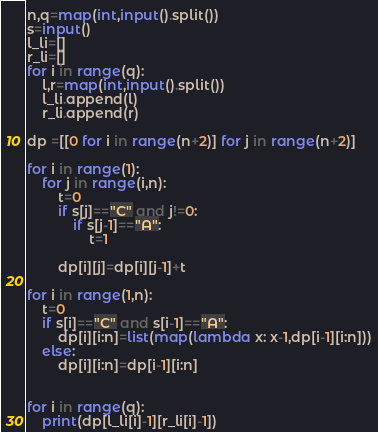<code> <loc_0><loc_0><loc_500><loc_500><_Python_>n,q=map(int,input().split())
s=input()
l_li=[]
r_li=[]
for i in range(q):
    l,r=map(int,input().split())
    l_li.append(l)
    r_li.append(r)
    
dp =[[0 for i in range(n+2)] for j in range(n+2)]

for i in range(1):
    for j in range(i,n):
        t=0
        if s[j]=="C" and j!=0:
            if s[j-1]=="A":
                t=1
        
        dp[i][j]=dp[i][j-1]+t
        
for i in range(1,n):
    t=0
    if s[i]=="C" and s[i-1]=="A":   
        dp[i][i:n]=list(map(lambda x: x-1,dp[i-1][i:n]))
    else:
        dp[i][i:n]=dp[i-1][i:n]       
        
        
for i in range(q):
    print(dp[l_li[i]-1][r_li[i]-1])
</code> 